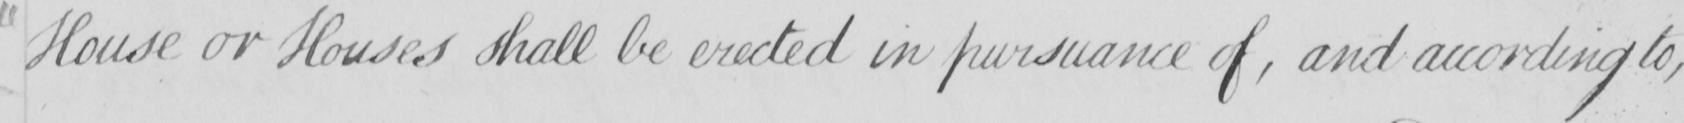What is written in this line of handwriting? House or Houses shall be erected in pursuance of , and according to , 